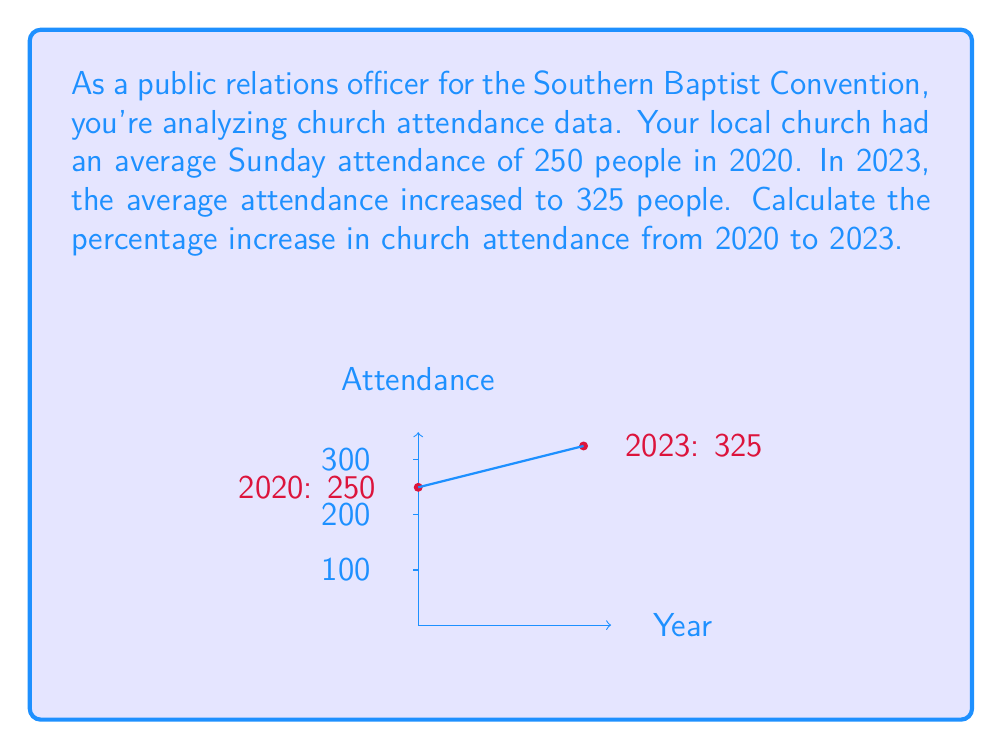Help me with this question. To calculate the percentage increase in church attendance, we'll follow these steps:

1. Calculate the absolute increase in attendance:
   $\text{Increase} = \text{New Value} - \text{Original Value}$
   $\text{Increase} = 325 - 250 = 75$ people

2. Calculate the percentage increase using the formula:
   $$\text{Percentage Increase} = \frac{\text{Increase}}{\text{Original Value}} \times 100\%$$

3. Substitute the values into the formula:
   $$\text{Percentage Increase} = \frac{75}{250} \times 100\%$$

4. Simplify the fraction:
   $$\text{Percentage Increase} = 0.3 \times 100\%$$

5. Convert to percentage:
   $$\text{Percentage Increase} = 30\%$$

Therefore, the church attendance increased by 30% from 2020 to 2023.
Answer: 30% 